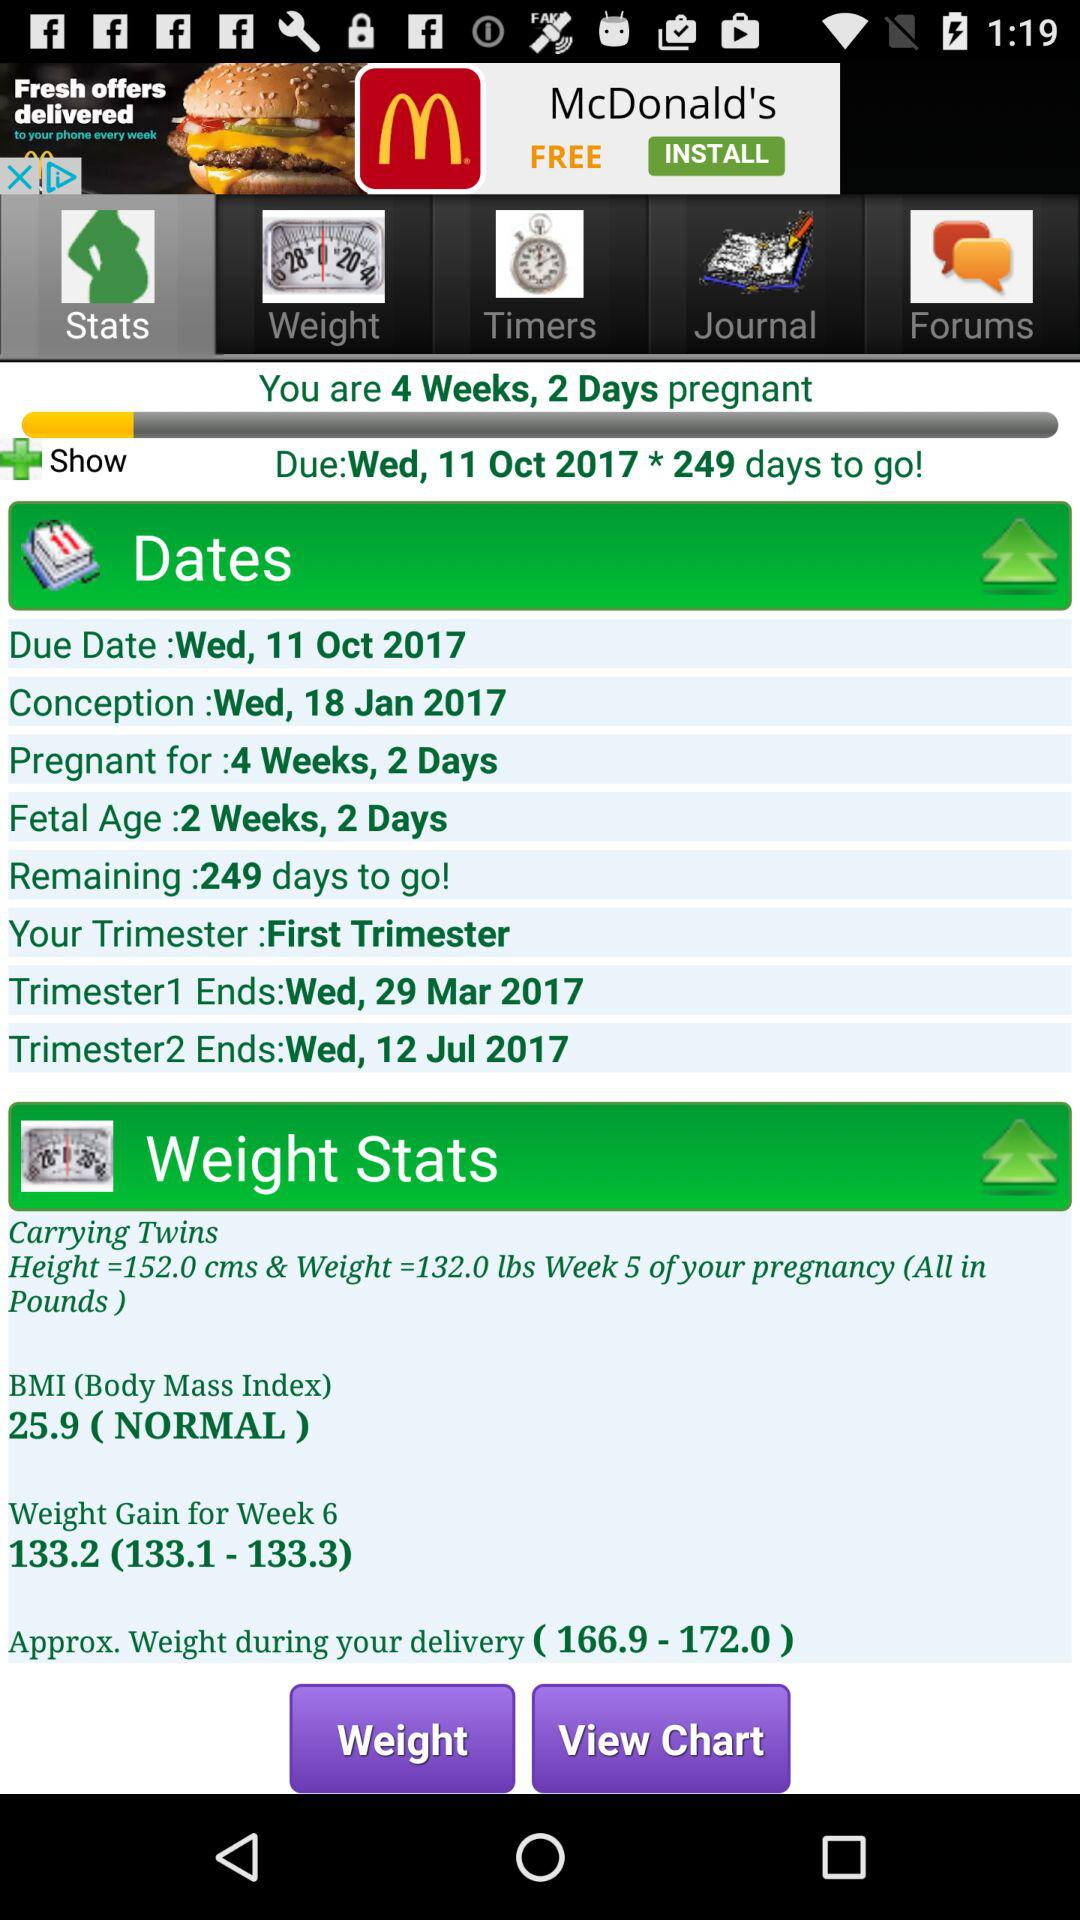How much weight gain in 6 weeks? The weight gain is 133.2. 